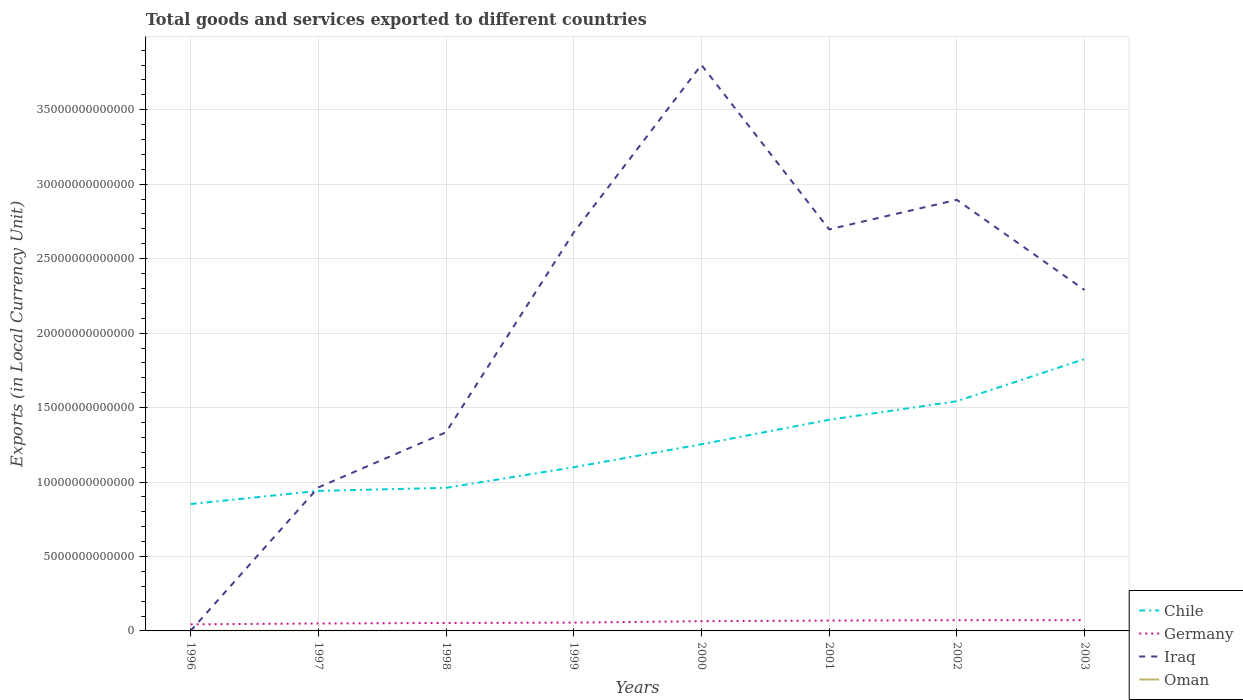How many different coloured lines are there?
Provide a succinct answer. 4. Does the line corresponding to Germany intersect with the line corresponding to Oman?
Keep it short and to the point. No. Is the number of lines equal to the number of legend labels?
Make the answer very short. Yes. Across all years, what is the maximum Amount of goods and services exports in Iraq?
Provide a short and direct response. 5.96e+08. What is the total Amount of goods and services exports in Oman in the graph?
Keep it short and to the point. -1.09e+09. What is the difference between the highest and the second highest Amount of goods and services exports in Germany?
Your response must be concise. 2.82e+11. How many lines are there?
Give a very brief answer. 4. What is the difference between two consecutive major ticks on the Y-axis?
Give a very brief answer. 5.00e+12. Are the values on the major ticks of Y-axis written in scientific E-notation?
Give a very brief answer. No. Does the graph contain any zero values?
Offer a very short reply. No. Does the graph contain grids?
Your answer should be very brief. Yes. Where does the legend appear in the graph?
Offer a very short reply. Bottom right. What is the title of the graph?
Your answer should be compact. Total goods and services exported to different countries. Does "Liechtenstein" appear as one of the legend labels in the graph?
Provide a short and direct response. No. What is the label or title of the X-axis?
Offer a very short reply. Years. What is the label or title of the Y-axis?
Ensure brevity in your answer.  Exports (in Local Currency Unit). What is the Exports (in Local Currency Unit) of Chile in 1996?
Ensure brevity in your answer.  8.52e+12. What is the Exports (in Local Currency Unit) in Germany in 1996?
Offer a terse response. 4.41e+11. What is the Exports (in Local Currency Unit) of Iraq in 1996?
Offer a very short reply. 5.96e+08. What is the Exports (in Local Currency Unit) in Oman in 1996?
Offer a very short reply. 2.93e+09. What is the Exports (in Local Currency Unit) in Chile in 1997?
Ensure brevity in your answer.  9.40e+12. What is the Exports (in Local Currency Unit) in Germany in 1997?
Provide a short and direct response. 4.99e+11. What is the Exports (in Local Currency Unit) in Iraq in 1997?
Provide a succinct answer. 9.64e+12. What is the Exports (in Local Currency Unit) of Oman in 1997?
Your response must be concise. 3.05e+09. What is the Exports (in Local Currency Unit) of Chile in 1998?
Offer a very short reply. 9.61e+12. What is the Exports (in Local Currency Unit) in Germany in 1998?
Your answer should be compact. 5.34e+11. What is the Exports (in Local Currency Unit) of Iraq in 1998?
Your response must be concise. 1.33e+13. What is the Exports (in Local Currency Unit) of Oman in 1998?
Provide a succinct answer. 2.27e+09. What is the Exports (in Local Currency Unit) in Chile in 1999?
Give a very brief answer. 1.10e+13. What is the Exports (in Local Currency Unit) of Germany in 1999?
Offer a very short reply. 5.58e+11. What is the Exports (in Local Currency Unit) of Iraq in 1999?
Your answer should be compact. 2.68e+13. What is the Exports (in Local Currency Unit) in Oman in 1999?
Offer a very short reply. 2.94e+09. What is the Exports (in Local Currency Unit) in Chile in 2000?
Give a very brief answer. 1.25e+13. What is the Exports (in Local Currency Unit) in Germany in 2000?
Your response must be concise. 6.53e+11. What is the Exports (in Local Currency Unit) in Iraq in 2000?
Give a very brief answer. 3.80e+13. What is the Exports (in Local Currency Unit) in Oman in 2000?
Make the answer very short. 4.03e+09. What is the Exports (in Local Currency Unit) in Chile in 2001?
Provide a short and direct response. 1.42e+13. What is the Exports (in Local Currency Unit) in Germany in 2001?
Make the answer very short. 6.95e+11. What is the Exports (in Local Currency Unit) of Iraq in 2001?
Your answer should be very brief. 2.70e+13. What is the Exports (in Local Currency Unit) of Oman in 2001?
Keep it short and to the point. 3.87e+09. What is the Exports (in Local Currency Unit) of Chile in 2002?
Your answer should be very brief. 1.54e+13. What is the Exports (in Local Currency Unit) in Germany in 2002?
Ensure brevity in your answer.  7.20e+11. What is the Exports (in Local Currency Unit) in Iraq in 2002?
Give a very brief answer. 2.89e+13. What is the Exports (in Local Currency Unit) of Oman in 2002?
Your answer should be compact. 3.80e+09. What is the Exports (in Local Currency Unit) of Chile in 2003?
Keep it short and to the point. 1.83e+13. What is the Exports (in Local Currency Unit) of Germany in 2003?
Provide a succinct answer. 7.24e+11. What is the Exports (in Local Currency Unit) in Iraq in 2003?
Offer a very short reply. 2.29e+13. What is the Exports (in Local Currency Unit) of Oman in 2003?
Your answer should be very brief. 4.14e+09. Across all years, what is the maximum Exports (in Local Currency Unit) in Chile?
Offer a very short reply. 1.83e+13. Across all years, what is the maximum Exports (in Local Currency Unit) of Germany?
Offer a terse response. 7.24e+11. Across all years, what is the maximum Exports (in Local Currency Unit) of Iraq?
Make the answer very short. 3.80e+13. Across all years, what is the maximum Exports (in Local Currency Unit) in Oman?
Provide a short and direct response. 4.14e+09. Across all years, what is the minimum Exports (in Local Currency Unit) of Chile?
Offer a terse response. 8.52e+12. Across all years, what is the minimum Exports (in Local Currency Unit) of Germany?
Offer a very short reply. 4.41e+11. Across all years, what is the minimum Exports (in Local Currency Unit) of Iraq?
Your answer should be compact. 5.96e+08. Across all years, what is the minimum Exports (in Local Currency Unit) of Oman?
Your answer should be very brief. 2.27e+09. What is the total Exports (in Local Currency Unit) in Chile in the graph?
Ensure brevity in your answer.  9.89e+13. What is the total Exports (in Local Currency Unit) of Germany in the graph?
Your answer should be very brief. 4.82e+12. What is the total Exports (in Local Currency Unit) in Iraq in the graph?
Keep it short and to the point. 1.67e+14. What is the total Exports (in Local Currency Unit) of Oman in the graph?
Your response must be concise. 2.70e+1. What is the difference between the Exports (in Local Currency Unit) in Chile in 1996 and that in 1997?
Keep it short and to the point. -8.84e+11. What is the difference between the Exports (in Local Currency Unit) in Germany in 1996 and that in 1997?
Your answer should be compact. -5.82e+1. What is the difference between the Exports (in Local Currency Unit) of Iraq in 1996 and that in 1997?
Provide a short and direct response. -9.64e+12. What is the difference between the Exports (in Local Currency Unit) of Oman in 1996 and that in 1997?
Make the answer very short. -1.21e+08. What is the difference between the Exports (in Local Currency Unit) of Chile in 1996 and that in 1998?
Give a very brief answer. -1.09e+12. What is the difference between the Exports (in Local Currency Unit) in Germany in 1996 and that in 1998?
Provide a succinct answer. -9.26e+1. What is the difference between the Exports (in Local Currency Unit) in Iraq in 1996 and that in 1998?
Offer a very short reply. -1.33e+13. What is the difference between the Exports (in Local Currency Unit) of Oman in 1996 and that in 1998?
Your answer should be compact. 6.53e+08. What is the difference between the Exports (in Local Currency Unit) in Chile in 1996 and that in 1999?
Ensure brevity in your answer.  -2.47e+12. What is the difference between the Exports (in Local Currency Unit) in Germany in 1996 and that in 1999?
Offer a terse response. -1.17e+11. What is the difference between the Exports (in Local Currency Unit) in Iraq in 1996 and that in 1999?
Provide a short and direct response. -2.68e+13. What is the difference between the Exports (in Local Currency Unit) of Oman in 1996 and that in 1999?
Offer a terse response. -1.50e+07. What is the difference between the Exports (in Local Currency Unit) of Chile in 1996 and that in 2000?
Your response must be concise. -4.01e+12. What is the difference between the Exports (in Local Currency Unit) of Germany in 1996 and that in 2000?
Provide a short and direct response. -2.11e+11. What is the difference between the Exports (in Local Currency Unit) of Iraq in 1996 and that in 2000?
Provide a short and direct response. -3.80e+13. What is the difference between the Exports (in Local Currency Unit) of Oman in 1996 and that in 2000?
Make the answer very short. -1.10e+09. What is the difference between the Exports (in Local Currency Unit) of Chile in 1996 and that in 2001?
Offer a very short reply. -5.66e+12. What is the difference between the Exports (in Local Currency Unit) in Germany in 1996 and that in 2001?
Your answer should be compact. -2.53e+11. What is the difference between the Exports (in Local Currency Unit) in Iraq in 1996 and that in 2001?
Provide a short and direct response. -2.70e+13. What is the difference between the Exports (in Local Currency Unit) of Oman in 1996 and that in 2001?
Make the answer very short. -9.41e+08. What is the difference between the Exports (in Local Currency Unit) of Chile in 1996 and that in 2002?
Offer a terse response. -6.91e+12. What is the difference between the Exports (in Local Currency Unit) of Germany in 1996 and that in 2002?
Your answer should be compact. -2.78e+11. What is the difference between the Exports (in Local Currency Unit) of Iraq in 1996 and that in 2002?
Provide a succinct answer. -2.89e+13. What is the difference between the Exports (in Local Currency Unit) in Oman in 1996 and that in 2002?
Your answer should be very brief. -8.77e+08. What is the difference between the Exports (in Local Currency Unit) in Chile in 1996 and that in 2003?
Your answer should be compact. -9.74e+12. What is the difference between the Exports (in Local Currency Unit) in Germany in 1996 and that in 2003?
Give a very brief answer. -2.82e+11. What is the difference between the Exports (in Local Currency Unit) in Iraq in 1996 and that in 2003?
Keep it short and to the point. -2.29e+13. What is the difference between the Exports (in Local Currency Unit) in Oman in 1996 and that in 2003?
Ensure brevity in your answer.  -1.21e+09. What is the difference between the Exports (in Local Currency Unit) in Chile in 1997 and that in 1998?
Provide a succinct answer. -2.04e+11. What is the difference between the Exports (in Local Currency Unit) in Germany in 1997 and that in 1998?
Provide a short and direct response. -3.44e+1. What is the difference between the Exports (in Local Currency Unit) of Iraq in 1997 and that in 1998?
Provide a short and direct response. -3.70e+12. What is the difference between the Exports (in Local Currency Unit) in Oman in 1997 and that in 1998?
Keep it short and to the point. 7.74e+08. What is the difference between the Exports (in Local Currency Unit) of Chile in 1997 and that in 1999?
Make the answer very short. -1.59e+12. What is the difference between the Exports (in Local Currency Unit) of Germany in 1997 and that in 1999?
Provide a short and direct response. -5.89e+1. What is the difference between the Exports (in Local Currency Unit) in Iraq in 1997 and that in 1999?
Provide a short and direct response. -1.71e+13. What is the difference between the Exports (in Local Currency Unit) in Oman in 1997 and that in 1999?
Offer a terse response. 1.06e+08. What is the difference between the Exports (in Local Currency Unit) of Chile in 1997 and that in 2000?
Ensure brevity in your answer.  -3.13e+12. What is the difference between the Exports (in Local Currency Unit) of Germany in 1997 and that in 2000?
Provide a short and direct response. -1.53e+11. What is the difference between the Exports (in Local Currency Unit) in Iraq in 1997 and that in 2000?
Provide a short and direct response. -2.84e+13. What is the difference between the Exports (in Local Currency Unit) in Oman in 1997 and that in 2000?
Provide a short and direct response. -9.80e+08. What is the difference between the Exports (in Local Currency Unit) in Chile in 1997 and that in 2001?
Keep it short and to the point. -4.78e+12. What is the difference between the Exports (in Local Currency Unit) in Germany in 1997 and that in 2001?
Your answer should be very brief. -1.95e+11. What is the difference between the Exports (in Local Currency Unit) in Iraq in 1997 and that in 2001?
Provide a short and direct response. -1.73e+13. What is the difference between the Exports (in Local Currency Unit) of Oman in 1997 and that in 2001?
Your answer should be compact. -8.20e+08. What is the difference between the Exports (in Local Currency Unit) of Chile in 1997 and that in 2002?
Provide a succinct answer. -6.02e+12. What is the difference between the Exports (in Local Currency Unit) of Germany in 1997 and that in 2002?
Provide a succinct answer. -2.20e+11. What is the difference between the Exports (in Local Currency Unit) of Iraq in 1997 and that in 2002?
Your response must be concise. -1.93e+13. What is the difference between the Exports (in Local Currency Unit) of Oman in 1997 and that in 2002?
Ensure brevity in your answer.  -7.56e+08. What is the difference between the Exports (in Local Currency Unit) in Chile in 1997 and that in 2003?
Keep it short and to the point. -8.85e+12. What is the difference between the Exports (in Local Currency Unit) in Germany in 1997 and that in 2003?
Your answer should be very brief. -2.24e+11. What is the difference between the Exports (in Local Currency Unit) in Iraq in 1997 and that in 2003?
Keep it short and to the point. -1.33e+13. What is the difference between the Exports (in Local Currency Unit) in Oman in 1997 and that in 2003?
Offer a terse response. -1.09e+09. What is the difference between the Exports (in Local Currency Unit) in Chile in 1998 and that in 1999?
Make the answer very short. -1.38e+12. What is the difference between the Exports (in Local Currency Unit) of Germany in 1998 and that in 1999?
Your answer should be compact. -2.45e+1. What is the difference between the Exports (in Local Currency Unit) of Iraq in 1998 and that in 1999?
Your answer should be compact. -1.34e+13. What is the difference between the Exports (in Local Currency Unit) in Oman in 1998 and that in 1999?
Your answer should be compact. -6.68e+08. What is the difference between the Exports (in Local Currency Unit) in Chile in 1998 and that in 2000?
Provide a succinct answer. -2.93e+12. What is the difference between the Exports (in Local Currency Unit) in Germany in 1998 and that in 2000?
Make the answer very short. -1.19e+11. What is the difference between the Exports (in Local Currency Unit) of Iraq in 1998 and that in 2000?
Your answer should be very brief. -2.47e+13. What is the difference between the Exports (in Local Currency Unit) in Oman in 1998 and that in 2000?
Your answer should be compact. -1.75e+09. What is the difference between the Exports (in Local Currency Unit) of Chile in 1998 and that in 2001?
Ensure brevity in your answer.  -4.57e+12. What is the difference between the Exports (in Local Currency Unit) of Germany in 1998 and that in 2001?
Make the answer very short. -1.61e+11. What is the difference between the Exports (in Local Currency Unit) in Iraq in 1998 and that in 2001?
Give a very brief answer. -1.36e+13. What is the difference between the Exports (in Local Currency Unit) of Oman in 1998 and that in 2001?
Your answer should be very brief. -1.59e+09. What is the difference between the Exports (in Local Currency Unit) in Chile in 1998 and that in 2002?
Your response must be concise. -5.82e+12. What is the difference between the Exports (in Local Currency Unit) in Germany in 1998 and that in 2002?
Give a very brief answer. -1.86e+11. What is the difference between the Exports (in Local Currency Unit) of Iraq in 1998 and that in 2002?
Ensure brevity in your answer.  -1.56e+13. What is the difference between the Exports (in Local Currency Unit) in Oman in 1998 and that in 2002?
Offer a very short reply. -1.53e+09. What is the difference between the Exports (in Local Currency Unit) in Chile in 1998 and that in 2003?
Give a very brief answer. -8.65e+12. What is the difference between the Exports (in Local Currency Unit) in Germany in 1998 and that in 2003?
Ensure brevity in your answer.  -1.90e+11. What is the difference between the Exports (in Local Currency Unit) in Iraq in 1998 and that in 2003?
Make the answer very short. -9.56e+12. What is the difference between the Exports (in Local Currency Unit) of Oman in 1998 and that in 2003?
Keep it short and to the point. -1.87e+09. What is the difference between the Exports (in Local Currency Unit) in Chile in 1999 and that in 2000?
Make the answer very short. -1.54e+12. What is the difference between the Exports (in Local Currency Unit) in Germany in 1999 and that in 2000?
Give a very brief answer. -9.41e+1. What is the difference between the Exports (in Local Currency Unit) in Iraq in 1999 and that in 2000?
Your answer should be compact. -1.13e+13. What is the difference between the Exports (in Local Currency Unit) of Oman in 1999 and that in 2000?
Offer a very short reply. -1.09e+09. What is the difference between the Exports (in Local Currency Unit) in Chile in 1999 and that in 2001?
Provide a succinct answer. -3.19e+12. What is the difference between the Exports (in Local Currency Unit) of Germany in 1999 and that in 2001?
Ensure brevity in your answer.  -1.36e+11. What is the difference between the Exports (in Local Currency Unit) of Iraq in 1999 and that in 2001?
Keep it short and to the point. -2.11e+11. What is the difference between the Exports (in Local Currency Unit) of Oman in 1999 and that in 2001?
Offer a very short reply. -9.26e+08. What is the difference between the Exports (in Local Currency Unit) of Chile in 1999 and that in 2002?
Your response must be concise. -4.43e+12. What is the difference between the Exports (in Local Currency Unit) in Germany in 1999 and that in 2002?
Your answer should be very brief. -1.61e+11. What is the difference between the Exports (in Local Currency Unit) in Iraq in 1999 and that in 2002?
Offer a very short reply. -2.19e+12. What is the difference between the Exports (in Local Currency Unit) of Oman in 1999 and that in 2002?
Give a very brief answer. -8.62e+08. What is the difference between the Exports (in Local Currency Unit) of Chile in 1999 and that in 2003?
Give a very brief answer. -7.26e+12. What is the difference between the Exports (in Local Currency Unit) in Germany in 1999 and that in 2003?
Your answer should be compact. -1.65e+11. What is the difference between the Exports (in Local Currency Unit) in Iraq in 1999 and that in 2003?
Make the answer very short. 3.86e+12. What is the difference between the Exports (in Local Currency Unit) in Oman in 1999 and that in 2003?
Provide a short and direct response. -1.20e+09. What is the difference between the Exports (in Local Currency Unit) in Chile in 2000 and that in 2001?
Offer a very short reply. -1.65e+12. What is the difference between the Exports (in Local Currency Unit) in Germany in 2000 and that in 2001?
Your answer should be very brief. -4.22e+1. What is the difference between the Exports (in Local Currency Unit) of Iraq in 2000 and that in 2001?
Provide a succinct answer. 1.10e+13. What is the difference between the Exports (in Local Currency Unit) in Oman in 2000 and that in 2001?
Offer a terse response. 1.60e+08. What is the difference between the Exports (in Local Currency Unit) of Chile in 2000 and that in 2002?
Keep it short and to the point. -2.89e+12. What is the difference between the Exports (in Local Currency Unit) in Germany in 2000 and that in 2002?
Make the answer very short. -6.72e+1. What is the difference between the Exports (in Local Currency Unit) of Iraq in 2000 and that in 2002?
Give a very brief answer. 9.06e+12. What is the difference between the Exports (in Local Currency Unit) in Oman in 2000 and that in 2002?
Your response must be concise. 2.24e+08. What is the difference between the Exports (in Local Currency Unit) of Chile in 2000 and that in 2003?
Make the answer very short. -5.72e+12. What is the difference between the Exports (in Local Currency Unit) in Germany in 2000 and that in 2003?
Your answer should be very brief. -7.11e+1. What is the difference between the Exports (in Local Currency Unit) in Iraq in 2000 and that in 2003?
Offer a terse response. 1.51e+13. What is the difference between the Exports (in Local Currency Unit) of Oman in 2000 and that in 2003?
Give a very brief answer. -1.12e+08. What is the difference between the Exports (in Local Currency Unit) of Chile in 2001 and that in 2002?
Provide a succinct answer. -1.25e+12. What is the difference between the Exports (in Local Currency Unit) in Germany in 2001 and that in 2002?
Offer a very short reply. -2.49e+1. What is the difference between the Exports (in Local Currency Unit) of Iraq in 2001 and that in 2002?
Offer a terse response. -1.98e+12. What is the difference between the Exports (in Local Currency Unit) of Oman in 2001 and that in 2002?
Offer a very short reply. 6.40e+07. What is the difference between the Exports (in Local Currency Unit) in Chile in 2001 and that in 2003?
Provide a succinct answer. -4.08e+12. What is the difference between the Exports (in Local Currency Unit) of Germany in 2001 and that in 2003?
Provide a short and direct response. -2.88e+1. What is the difference between the Exports (in Local Currency Unit) in Iraq in 2001 and that in 2003?
Keep it short and to the point. 4.07e+12. What is the difference between the Exports (in Local Currency Unit) in Oman in 2001 and that in 2003?
Offer a terse response. -2.72e+08. What is the difference between the Exports (in Local Currency Unit) of Chile in 2002 and that in 2003?
Provide a short and direct response. -2.83e+12. What is the difference between the Exports (in Local Currency Unit) in Germany in 2002 and that in 2003?
Give a very brief answer. -3.90e+09. What is the difference between the Exports (in Local Currency Unit) in Iraq in 2002 and that in 2003?
Provide a succinct answer. 6.05e+12. What is the difference between the Exports (in Local Currency Unit) of Oman in 2002 and that in 2003?
Your answer should be very brief. -3.36e+08. What is the difference between the Exports (in Local Currency Unit) of Chile in 1996 and the Exports (in Local Currency Unit) of Germany in 1997?
Offer a terse response. 8.02e+12. What is the difference between the Exports (in Local Currency Unit) of Chile in 1996 and the Exports (in Local Currency Unit) of Iraq in 1997?
Keep it short and to the point. -1.12e+12. What is the difference between the Exports (in Local Currency Unit) in Chile in 1996 and the Exports (in Local Currency Unit) in Oman in 1997?
Provide a succinct answer. 8.52e+12. What is the difference between the Exports (in Local Currency Unit) in Germany in 1996 and the Exports (in Local Currency Unit) in Iraq in 1997?
Provide a short and direct response. -9.20e+12. What is the difference between the Exports (in Local Currency Unit) in Germany in 1996 and the Exports (in Local Currency Unit) in Oman in 1997?
Ensure brevity in your answer.  4.38e+11. What is the difference between the Exports (in Local Currency Unit) in Iraq in 1996 and the Exports (in Local Currency Unit) in Oman in 1997?
Your answer should be compact. -2.45e+09. What is the difference between the Exports (in Local Currency Unit) in Chile in 1996 and the Exports (in Local Currency Unit) in Germany in 1998?
Make the answer very short. 7.99e+12. What is the difference between the Exports (in Local Currency Unit) in Chile in 1996 and the Exports (in Local Currency Unit) in Iraq in 1998?
Your response must be concise. -4.82e+12. What is the difference between the Exports (in Local Currency Unit) in Chile in 1996 and the Exports (in Local Currency Unit) in Oman in 1998?
Your response must be concise. 8.52e+12. What is the difference between the Exports (in Local Currency Unit) of Germany in 1996 and the Exports (in Local Currency Unit) of Iraq in 1998?
Make the answer very short. -1.29e+13. What is the difference between the Exports (in Local Currency Unit) of Germany in 1996 and the Exports (in Local Currency Unit) of Oman in 1998?
Your response must be concise. 4.39e+11. What is the difference between the Exports (in Local Currency Unit) of Iraq in 1996 and the Exports (in Local Currency Unit) of Oman in 1998?
Make the answer very short. -1.68e+09. What is the difference between the Exports (in Local Currency Unit) of Chile in 1996 and the Exports (in Local Currency Unit) of Germany in 1999?
Make the answer very short. 7.96e+12. What is the difference between the Exports (in Local Currency Unit) in Chile in 1996 and the Exports (in Local Currency Unit) in Iraq in 1999?
Offer a terse response. -1.82e+13. What is the difference between the Exports (in Local Currency Unit) of Chile in 1996 and the Exports (in Local Currency Unit) of Oman in 1999?
Give a very brief answer. 8.52e+12. What is the difference between the Exports (in Local Currency Unit) of Germany in 1996 and the Exports (in Local Currency Unit) of Iraq in 1999?
Provide a short and direct response. -2.63e+13. What is the difference between the Exports (in Local Currency Unit) of Germany in 1996 and the Exports (in Local Currency Unit) of Oman in 1999?
Provide a succinct answer. 4.38e+11. What is the difference between the Exports (in Local Currency Unit) of Iraq in 1996 and the Exports (in Local Currency Unit) of Oman in 1999?
Ensure brevity in your answer.  -2.35e+09. What is the difference between the Exports (in Local Currency Unit) of Chile in 1996 and the Exports (in Local Currency Unit) of Germany in 2000?
Offer a terse response. 7.87e+12. What is the difference between the Exports (in Local Currency Unit) in Chile in 1996 and the Exports (in Local Currency Unit) in Iraq in 2000?
Ensure brevity in your answer.  -2.95e+13. What is the difference between the Exports (in Local Currency Unit) of Chile in 1996 and the Exports (in Local Currency Unit) of Oman in 2000?
Offer a terse response. 8.52e+12. What is the difference between the Exports (in Local Currency Unit) in Germany in 1996 and the Exports (in Local Currency Unit) in Iraq in 2000?
Offer a terse response. -3.76e+13. What is the difference between the Exports (in Local Currency Unit) of Germany in 1996 and the Exports (in Local Currency Unit) of Oman in 2000?
Provide a succinct answer. 4.37e+11. What is the difference between the Exports (in Local Currency Unit) in Iraq in 1996 and the Exports (in Local Currency Unit) in Oman in 2000?
Your response must be concise. -3.43e+09. What is the difference between the Exports (in Local Currency Unit) of Chile in 1996 and the Exports (in Local Currency Unit) of Germany in 2001?
Ensure brevity in your answer.  7.83e+12. What is the difference between the Exports (in Local Currency Unit) in Chile in 1996 and the Exports (in Local Currency Unit) in Iraq in 2001?
Offer a terse response. -1.84e+13. What is the difference between the Exports (in Local Currency Unit) of Chile in 1996 and the Exports (in Local Currency Unit) of Oman in 2001?
Offer a very short reply. 8.52e+12. What is the difference between the Exports (in Local Currency Unit) in Germany in 1996 and the Exports (in Local Currency Unit) in Iraq in 2001?
Keep it short and to the point. -2.65e+13. What is the difference between the Exports (in Local Currency Unit) of Germany in 1996 and the Exports (in Local Currency Unit) of Oman in 2001?
Provide a succinct answer. 4.37e+11. What is the difference between the Exports (in Local Currency Unit) of Iraq in 1996 and the Exports (in Local Currency Unit) of Oman in 2001?
Give a very brief answer. -3.27e+09. What is the difference between the Exports (in Local Currency Unit) in Chile in 1996 and the Exports (in Local Currency Unit) in Germany in 2002?
Offer a very short reply. 7.80e+12. What is the difference between the Exports (in Local Currency Unit) of Chile in 1996 and the Exports (in Local Currency Unit) of Iraq in 2002?
Keep it short and to the point. -2.04e+13. What is the difference between the Exports (in Local Currency Unit) in Chile in 1996 and the Exports (in Local Currency Unit) in Oman in 2002?
Provide a short and direct response. 8.52e+12. What is the difference between the Exports (in Local Currency Unit) in Germany in 1996 and the Exports (in Local Currency Unit) in Iraq in 2002?
Offer a very short reply. -2.85e+13. What is the difference between the Exports (in Local Currency Unit) in Germany in 1996 and the Exports (in Local Currency Unit) in Oman in 2002?
Your answer should be very brief. 4.37e+11. What is the difference between the Exports (in Local Currency Unit) in Iraq in 1996 and the Exports (in Local Currency Unit) in Oman in 2002?
Make the answer very short. -3.21e+09. What is the difference between the Exports (in Local Currency Unit) of Chile in 1996 and the Exports (in Local Currency Unit) of Germany in 2003?
Ensure brevity in your answer.  7.80e+12. What is the difference between the Exports (in Local Currency Unit) of Chile in 1996 and the Exports (in Local Currency Unit) of Iraq in 2003?
Your response must be concise. -1.44e+13. What is the difference between the Exports (in Local Currency Unit) in Chile in 1996 and the Exports (in Local Currency Unit) in Oman in 2003?
Your response must be concise. 8.52e+12. What is the difference between the Exports (in Local Currency Unit) in Germany in 1996 and the Exports (in Local Currency Unit) in Iraq in 2003?
Provide a succinct answer. -2.25e+13. What is the difference between the Exports (in Local Currency Unit) in Germany in 1996 and the Exports (in Local Currency Unit) in Oman in 2003?
Offer a very short reply. 4.37e+11. What is the difference between the Exports (in Local Currency Unit) in Iraq in 1996 and the Exports (in Local Currency Unit) in Oman in 2003?
Your answer should be compact. -3.54e+09. What is the difference between the Exports (in Local Currency Unit) of Chile in 1997 and the Exports (in Local Currency Unit) of Germany in 1998?
Offer a terse response. 8.87e+12. What is the difference between the Exports (in Local Currency Unit) of Chile in 1997 and the Exports (in Local Currency Unit) of Iraq in 1998?
Make the answer very short. -3.94e+12. What is the difference between the Exports (in Local Currency Unit) of Chile in 1997 and the Exports (in Local Currency Unit) of Oman in 1998?
Offer a terse response. 9.40e+12. What is the difference between the Exports (in Local Currency Unit) of Germany in 1997 and the Exports (in Local Currency Unit) of Iraq in 1998?
Your answer should be compact. -1.28e+13. What is the difference between the Exports (in Local Currency Unit) of Germany in 1997 and the Exports (in Local Currency Unit) of Oman in 1998?
Provide a succinct answer. 4.97e+11. What is the difference between the Exports (in Local Currency Unit) in Iraq in 1997 and the Exports (in Local Currency Unit) in Oman in 1998?
Give a very brief answer. 9.63e+12. What is the difference between the Exports (in Local Currency Unit) in Chile in 1997 and the Exports (in Local Currency Unit) in Germany in 1999?
Give a very brief answer. 8.85e+12. What is the difference between the Exports (in Local Currency Unit) in Chile in 1997 and the Exports (in Local Currency Unit) in Iraq in 1999?
Keep it short and to the point. -1.74e+13. What is the difference between the Exports (in Local Currency Unit) in Chile in 1997 and the Exports (in Local Currency Unit) in Oman in 1999?
Provide a succinct answer. 9.40e+12. What is the difference between the Exports (in Local Currency Unit) in Germany in 1997 and the Exports (in Local Currency Unit) in Iraq in 1999?
Give a very brief answer. -2.63e+13. What is the difference between the Exports (in Local Currency Unit) of Germany in 1997 and the Exports (in Local Currency Unit) of Oman in 1999?
Provide a succinct answer. 4.97e+11. What is the difference between the Exports (in Local Currency Unit) in Iraq in 1997 and the Exports (in Local Currency Unit) in Oman in 1999?
Provide a short and direct response. 9.63e+12. What is the difference between the Exports (in Local Currency Unit) in Chile in 1997 and the Exports (in Local Currency Unit) in Germany in 2000?
Offer a terse response. 8.75e+12. What is the difference between the Exports (in Local Currency Unit) of Chile in 1997 and the Exports (in Local Currency Unit) of Iraq in 2000?
Make the answer very short. -2.86e+13. What is the difference between the Exports (in Local Currency Unit) of Chile in 1997 and the Exports (in Local Currency Unit) of Oman in 2000?
Give a very brief answer. 9.40e+12. What is the difference between the Exports (in Local Currency Unit) in Germany in 1997 and the Exports (in Local Currency Unit) in Iraq in 2000?
Ensure brevity in your answer.  -3.75e+13. What is the difference between the Exports (in Local Currency Unit) in Germany in 1997 and the Exports (in Local Currency Unit) in Oman in 2000?
Provide a short and direct response. 4.95e+11. What is the difference between the Exports (in Local Currency Unit) in Iraq in 1997 and the Exports (in Local Currency Unit) in Oman in 2000?
Your answer should be very brief. 9.63e+12. What is the difference between the Exports (in Local Currency Unit) in Chile in 1997 and the Exports (in Local Currency Unit) in Germany in 2001?
Ensure brevity in your answer.  8.71e+12. What is the difference between the Exports (in Local Currency Unit) of Chile in 1997 and the Exports (in Local Currency Unit) of Iraq in 2001?
Offer a very short reply. -1.76e+13. What is the difference between the Exports (in Local Currency Unit) of Chile in 1997 and the Exports (in Local Currency Unit) of Oman in 2001?
Offer a very short reply. 9.40e+12. What is the difference between the Exports (in Local Currency Unit) in Germany in 1997 and the Exports (in Local Currency Unit) in Iraq in 2001?
Your response must be concise. -2.65e+13. What is the difference between the Exports (in Local Currency Unit) of Germany in 1997 and the Exports (in Local Currency Unit) of Oman in 2001?
Provide a succinct answer. 4.96e+11. What is the difference between the Exports (in Local Currency Unit) in Iraq in 1997 and the Exports (in Local Currency Unit) in Oman in 2001?
Your answer should be compact. 9.63e+12. What is the difference between the Exports (in Local Currency Unit) of Chile in 1997 and the Exports (in Local Currency Unit) of Germany in 2002?
Your answer should be very brief. 8.68e+12. What is the difference between the Exports (in Local Currency Unit) in Chile in 1997 and the Exports (in Local Currency Unit) in Iraq in 2002?
Offer a terse response. -1.95e+13. What is the difference between the Exports (in Local Currency Unit) in Chile in 1997 and the Exports (in Local Currency Unit) in Oman in 2002?
Provide a succinct answer. 9.40e+12. What is the difference between the Exports (in Local Currency Unit) in Germany in 1997 and the Exports (in Local Currency Unit) in Iraq in 2002?
Make the answer very short. -2.85e+13. What is the difference between the Exports (in Local Currency Unit) of Germany in 1997 and the Exports (in Local Currency Unit) of Oman in 2002?
Your response must be concise. 4.96e+11. What is the difference between the Exports (in Local Currency Unit) of Iraq in 1997 and the Exports (in Local Currency Unit) of Oman in 2002?
Give a very brief answer. 9.63e+12. What is the difference between the Exports (in Local Currency Unit) in Chile in 1997 and the Exports (in Local Currency Unit) in Germany in 2003?
Keep it short and to the point. 8.68e+12. What is the difference between the Exports (in Local Currency Unit) in Chile in 1997 and the Exports (in Local Currency Unit) in Iraq in 2003?
Give a very brief answer. -1.35e+13. What is the difference between the Exports (in Local Currency Unit) of Chile in 1997 and the Exports (in Local Currency Unit) of Oman in 2003?
Make the answer very short. 9.40e+12. What is the difference between the Exports (in Local Currency Unit) in Germany in 1997 and the Exports (in Local Currency Unit) in Iraq in 2003?
Offer a very short reply. -2.24e+13. What is the difference between the Exports (in Local Currency Unit) of Germany in 1997 and the Exports (in Local Currency Unit) of Oman in 2003?
Your answer should be compact. 4.95e+11. What is the difference between the Exports (in Local Currency Unit) of Iraq in 1997 and the Exports (in Local Currency Unit) of Oman in 2003?
Provide a short and direct response. 9.63e+12. What is the difference between the Exports (in Local Currency Unit) in Chile in 1998 and the Exports (in Local Currency Unit) in Germany in 1999?
Your answer should be very brief. 9.05e+12. What is the difference between the Exports (in Local Currency Unit) in Chile in 1998 and the Exports (in Local Currency Unit) in Iraq in 1999?
Offer a terse response. -1.71e+13. What is the difference between the Exports (in Local Currency Unit) in Chile in 1998 and the Exports (in Local Currency Unit) in Oman in 1999?
Your answer should be compact. 9.61e+12. What is the difference between the Exports (in Local Currency Unit) in Germany in 1998 and the Exports (in Local Currency Unit) in Iraq in 1999?
Keep it short and to the point. -2.62e+13. What is the difference between the Exports (in Local Currency Unit) of Germany in 1998 and the Exports (in Local Currency Unit) of Oman in 1999?
Provide a succinct answer. 5.31e+11. What is the difference between the Exports (in Local Currency Unit) of Iraq in 1998 and the Exports (in Local Currency Unit) of Oman in 1999?
Your answer should be very brief. 1.33e+13. What is the difference between the Exports (in Local Currency Unit) of Chile in 1998 and the Exports (in Local Currency Unit) of Germany in 2000?
Your response must be concise. 8.96e+12. What is the difference between the Exports (in Local Currency Unit) in Chile in 1998 and the Exports (in Local Currency Unit) in Iraq in 2000?
Offer a terse response. -2.84e+13. What is the difference between the Exports (in Local Currency Unit) of Chile in 1998 and the Exports (in Local Currency Unit) of Oman in 2000?
Offer a terse response. 9.60e+12. What is the difference between the Exports (in Local Currency Unit) of Germany in 1998 and the Exports (in Local Currency Unit) of Iraq in 2000?
Make the answer very short. -3.75e+13. What is the difference between the Exports (in Local Currency Unit) in Germany in 1998 and the Exports (in Local Currency Unit) in Oman in 2000?
Your answer should be very brief. 5.30e+11. What is the difference between the Exports (in Local Currency Unit) in Iraq in 1998 and the Exports (in Local Currency Unit) in Oman in 2000?
Make the answer very short. 1.33e+13. What is the difference between the Exports (in Local Currency Unit) in Chile in 1998 and the Exports (in Local Currency Unit) in Germany in 2001?
Keep it short and to the point. 8.91e+12. What is the difference between the Exports (in Local Currency Unit) in Chile in 1998 and the Exports (in Local Currency Unit) in Iraq in 2001?
Your answer should be compact. -1.74e+13. What is the difference between the Exports (in Local Currency Unit) in Chile in 1998 and the Exports (in Local Currency Unit) in Oman in 2001?
Keep it short and to the point. 9.60e+12. What is the difference between the Exports (in Local Currency Unit) in Germany in 1998 and the Exports (in Local Currency Unit) in Iraq in 2001?
Your response must be concise. -2.64e+13. What is the difference between the Exports (in Local Currency Unit) in Germany in 1998 and the Exports (in Local Currency Unit) in Oman in 2001?
Make the answer very short. 5.30e+11. What is the difference between the Exports (in Local Currency Unit) in Iraq in 1998 and the Exports (in Local Currency Unit) in Oman in 2001?
Keep it short and to the point. 1.33e+13. What is the difference between the Exports (in Local Currency Unit) of Chile in 1998 and the Exports (in Local Currency Unit) of Germany in 2002?
Ensure brevity in your answer.  8.89e+12. What is the difference between the Exports (in Local Currency Unit) of Chile in 1998 and the Exports (in Local Currency Unit) of Iraq in 2002?
Your answer should be very brief. -1.93e+13. What is the difference between the Exports (in Local Currency Unit) of Chile in 1998 and the Exports (in Local Currency Unit) of Oman in 2002?
Ensure brevity in your answer.  9.60e+12. What is the difference between the Exports (in Local Currency Unit) of Germany in 1998 and the Exports (in Local Currency Unit) of Iraq in 2002?
Provide a succinct answer. -2.84e+13. What is the difference between the Exports (in Local Currency Unit) in Germany in 1998 and the Exports (in Local Currency Unit) in Oman in 2002?
Keep it short and to the point. 5.30e+11. What is the difference between the Exports (in Local Currency Unit) in Iraq in 1998 and the Exports (in Local Currency Unit) in Oman in 2002?
Your answer should be compact. 1.33e+13. What is the difference between the Exports (in Local Currency Unit) in Chile in 1998 and the Exports (in Local Currency Unit) in Germany in 2003?
Your response must be concise. 8.89e+12. What is the difference between the Exports (in Local Currency Unit) of Chile in 1998 and the Exports (in Local Currency Unit) of Iraq in 2003?
Provide a short and direct response. -1.33e+13. What is the difference between the Exports (in Local Currency Unit) of Chile in 1998 and the Exports (in Local Currency Unit) of Oman in 2003?
Make the answer very short. 9.60e+12. What is the difference between the Exports (in Local Currency Unit) in Germany in 1998 and the Exports (in Local Currency Unit) in Iraq in 2003?
Keep it short and to the point. -2.24e+13. What is the difference between the Exports (in Local Currency Unit) in Germany in 1998 and the Exports (in Local Currency Unit) in Oman in 2003?
Your response must be concise. 5.30e+11. What is the difference between the Exports (in Local Currency Unit) in Iraq in 1998 and the Exports (in Local Currency Unit) in Oman in 2003?
Ensure brevity in your answer.  1.33e+13. What is the difference between the Exports (in Local Currency Unit) in Chile in 1999 and the Exports (in Local Currency Unit) in Germany in 2000?
Give a very brief answer. 1.03e+13. What is the difference between the Exports (in Local Currency Unit) of Chile in 1999 and the Exports (in Local Currency Unit) of Iraq in 2000?
Offer a very short reply. -2.70e+13. What is the difference between the Exports (in Local Currency Unit) of Chile in 1999 and the Exports (in Local Currency Unit) of Oman in 2000?
Your answer should be compact. 1.10e+13. What is the difference between the Exports (in Local Currency Unit) of Germany in 1999 and the Exports (in Local Currency Unit) of Iraq in 2000?
Keep it short and to the point. -3.75e+13. What is the difference between the Exports (in Local Currency Unit) of Germany in 1999 and the Exports (in Local Currency Unit) of Oman in 2000?
Provide a short and direct response. 5.54e+11. What is the difference between the Exports (in Local Currency Unit) in Iraq in 1999 and the Exports (in Local Currency Unit) in Oman in 2000?
Offer a terse response. 2.68e+13. What is the difference between the Exports (in Local Currency Unit) in Chile in 1999 and the Exports (in Local Currency Unit) in Germany in 2001?
Ensure brevity in your answer.  1.03e+13. What is the difference between the Exports (in Local Currency Unit) in Chile in 1999 and the Exports (in Local Currency Unit) in Iraq in 2001?
Provide a short and direct response. -1.60e+13. What is the difference between the Exports (in Local Currency Unit) of Chile in 1999 and the Exports (in Local Currency Unit) of Oman in 2001?
Ensure brevity in your answer.  1.10e+13. What is the difference between the Exports (in Local Currency Unit) in Germany in 1999 and the Exports (in Local Currency Unit) in Iraq in 2001?
Provide a succinct answer. -2.64e+13. What is the difference between the Exports (in Local Currency Unit) in Germany in 1999 and the Exports (in Local Currency Unit) in Oman in 2001?
Provide a succinct answer. 5.55e+11. What is the difference between the Exports (in Local Currency Unit) of Iraq in 1999 and the Exports (in Local Currency Unit) of Oman in 2001?
Your answer should be compact. 2.68e+13. What is the difference between the Exports (in Local Currency Unit) of Chile in 1999 and the Exports (in Local Currency Unit) of Germany in 2002?
Offer a very short reply. 1.03e+13. What is the difference between the Exports (in Local Currency Unit) in Chile in 1999 and the Exports (in Local Currency Unit) in Iraq in 2002?
Provide a succinct answer. -1.80e+13. What is the difference between the Exports (in Local Currency Unit) in Chile in 1999 and the Exports (in Local Currency Unit) in Oman in 2002?
Provide a succinct answer. 1.10e+13. What is the difference between the Exports (in Local Currency Unit) in Germany in 1999 and the Exports (in Local Currency Unit) in Iraq in 2002?
Your response must be concise. -2.84e+13. What is the difference between the Exports (in Local Currency Unit) in Germany in 1999 and the Exports (in Local Currency Unit) in Oman in 2002?
Keep it short and to the point. 5.55e+11. What is the difference between the Exports (in Local Currency Unit) of Iraq in 1999 and the Exports (in Local Currency Unit) of Oman in 2002?
Your answer should be compact. 2.68e+13. What is the difference between the Exports (in Local Currency Unit) of Chile in 1999 and the Exports (in Local Currency Unit) of Germany in 2003?
Your answer should be very brief. 1.03e+13. What is the difference between the Exports (in Local Currency Unit) of Chile in 1999 and the Exports (in Local Currency Unit) of Iraq in 2003?
Your answer should be compact. -1.19e+13. What is the difference between the Exports (in Local Currency Unit) of Chile in 1999 and the Exports (in Local Currency Unit) of Oman in 2003?
Keep it short and to the point. 1.10e+13. What is the difference between the Exports (in Local Currency Unit) of Germany in 1999 and the Exports (in Local Currency Unit) of Iraq in 2003?
Your response must be concise. -2.23e+13. What is the difference between the Exports (in Local Currency Unit) in Germany in 1999 and the Exports (in Local Currency Unit) in Oman in 2003?
Your response must be concise. 5.54e+11. What is the difference between the Exports (in Local Currency Unit) in Iraq in 1999 and the Exports (in Local Currency Unit) in Oman in 2003?
Your response must be concise. 2.68e+13. What is the difference between the Exports (in Local Currency Unit) of Chile in 2000 and the Exports (in Local Currency Unit) of Germany in 2001?
Give a very brief answer. 1.18e+13. What is the difference between the Exports (in Local Currency Unit) in Chile in 2000 and the Exports (in Local Currency Unit) in Iraq in 2001?
Your answer should be compact. -1.44e+13. What is the difference between the Exports (in Local Currency Unit) of Chile in 2000 and the Exports (in Local Currency Unit) of Oman in 2001?
Give a very brief answer. 1.25e+13. What is the difference between the Exports (in Local Currency Unit) in Germany in 2000 and the Exports (in Local Currency Unit) in Iraq in 2001?
Your response must be concise. -2.63e+13. What is the difference between the Exports (in Local Currency Unit) in Germany in 2000 and the Exports (in Local Currency Unit) in Oman in 2001?
Make the answer very short. 6.49e+11. What is the difference between the Exports (in Local Currency Unit) in Iraq in 2000 and the Exports (in Local Currency Unit) in Oman in 2001?
Offer a terse response. 3.80e+13. What is the difference between the Exports (in Local Currency Unit) in Chile in 2000 and the Exports (in Local Currency Unit) in Germany in 2002?
Ensure brevity in your answer.  1.18e+13. What is the difference between the Exports (in Local Currency Unit) of Chile in 2000 and the Exports (in Local Currency Unit) of Iraq in 2002?
Your answer should be compact. -1.64e+13. What is the difference between the Exports (in Local Currency Unit) of Chile in 2000 and the Exports (in Local Currency Unit) of Oman in 2002?
Ensure brevity in your answer.  1.25e+13. What is the difference between the Exports (in Local Currency Unit) of Germany in 2000 and the Exports (in Local Currency Unit) of Iraq in 2002?
Provide a succinct answer. -2.83e+13. What is the difference between the Exports (in Local Currency Unit) of Germany in 2000 and the Exports (in Local Currency Unit) of Oman in 2002?
Make the answer very short. 6.49e+11. What is the difference between the Exports (in Local Currency Unit) of Iraq in 2000 and the Exports (in Local Currency Unit) of Oman in 2002?
Ensure brevity in your answer.  3.80e+13. What is the difference between the Exports (in Local Currency Unit) of Chile in 2000 and the Exports (in Local Currency Unit) of Germany in 2003?
Keep it short and to the point. 1.18e+13. What is the difference between the Exports (in Local Currency Unit) of Chile in 2000 and the Exports (in Local Currency Unit) of Iraq in 2003?
Offer a very short reply. -1.04e+13. What is the difference between the Exports (in Local Currency Unit) of Chile in 2000 and the Exports (in Local Currency Unit) of Oman in 2003?
Your answer should be very brief. 1.25e+13. What is the difference between the Exports (in Local Currency Unit) of Germany in 2000 and the Exports (in Local Currency Unit) of Iraq in 2003?
Provide a succinct answer. -2.22e+13. What is the difference between the Exports (in Local Currency Unit) in Germany in 2000 and the Exports (in Local Currency Unit) in Oman in 2003?
Your response must be concise. 6.48e+11. What is the difference between the Exports (in Local Currency Unit) of Iraq in 2000 and the Exports (in Local Currency Unit) of Oman in 2003?
Your answer should be compact. 3.80e+13. What is the difference between the Exports (in Local Currency Unit) in Chile in 2001 and the Exports (in Local Currency Unit) in Germany in 2002?
Your answer should be very brief. 1.35e+13. What is the difference between the Exports (in Local Currency Unit) of Chile in 2001 and the Exports (in Local Currency Unit) of Iraq in 2002?
Your answer should be compact. -1.48e+13. What is the difference between the Exports (in Local Currency Unit) of Chile in 2001 and the Exports (in Local Currency Unit) of Oman in 2002?
Make the answer very short. 1.42e+13. What is the difference between the Exports (in Local Currency Unit) of Germany in 2001 and the Exports (in Local Currency Unit) of Iraq in 2002?
Ensure brevity in your answer.  -2.83e+13. What is the difference between the Exports (in Local Currency Unit) in Germany in 2001 and the Exports (in Local Currency Unit) in Oman in 2002?
Your answer should be compact. 6.91e+11. What is the difference between the Exports (in Local Currency Unit) in Iraq in 2001 and the Exports (in Local Currency Unit) in Oman in 2002?
Your answer should be compact. 2.70e+13. What is the difference between the Exports (in Local Currency Unit) of Chile in 2001 and the Exports (in Local Currency Unit) of Germany in 2003?
Your answer should be very brief. 1.35e+13. What is the difference between the Exports (in Local Currency Unit) of Chile in 2001 and the Exports (in Local Currency Unit) of Iraq in 2003?
Keep it short and to the point. -8.72e+12. What is the difference between the Exports (in Local Currency Unit) of Chile in 2001 and the Exports (in Local Currency Unit) of Oman in 2003?
Provide a succinct answer. 1.42e+13. What is the difference between the Exports (in Local Currency Unit) of Germany in 2001 and the Exports (in Local Currency Unit) of Iraq in 2003?
Keep it short and to the point. -2.22e+13. What is the difference between the Exports (in Local Currency Unit) in Germany in 2001 and the Exports (in Local Currency Unit) in Oman in 2003?
Ensure brevity in your answer.  6.91e+11. What is the difference between the Exports (in Local Currency Unit) of Iraq in 2001 and the Exports (in Local Currency Unit) of Oman in 2003?
Your answer should be compact. 2.70e+13. What is the difference between the Exports (in Local Currency Unit) of Chile in 2002 and the Exports (in Local Currency Unit) of Germany in 2003?
Your response must be concise. 1.47e+13. What is the difference between the Exports (in Local Currency Unit) of Chile in 2002 and the Exports (in Local Currency Unit) of Iraq in 2003?
Provide a succinct answer. -7.47e+12. What is the difference between the Exports (in Local Currency Unit) of Chile in 2002 and the Exports (in Local Currency Unit) of Oman in 2003?
Ensure brevity in your answer.  1.54e+13. What is the difference between the Exports (in Local Currency Unit) of Germany in 2002 and the Exports (in Local Currency Unit) of Iraq in 2003?
Offer a very short reply. -2.22e+13. What is the difference between the Exports (in Local Currency Unit) in Germany in 2002 and the Exports (in Local Currency Unit) in Oman in 2003?
Your answer should be compact. 7.16e+11. What is the difference between the Exports (in Local Currency Unit) of Iraq in 2002 and the Exports (in Local Currency Unit) of Oman in 2003?
Make the answer very short. 2.89e+13. What is the average Exports (in Local Currency Unit) in Chile per year?
Your response must be concise. 1.24e+13. What is the average Exports (in Local Currency Unit) of Germany per year?
Your answer should be compact. 6.03e+11. What is the average Exports (in Local Currency Unit) in Iraq per year?
Make the answer very short. 2.08e+13. What is the average Exports (in Local Currency Unit) of Oman per year?
Ensure brevity in your answer.  3.38e+09. In the year 1996, what is the difference between the Exports (in Local Currency Unit) in Chile and Exports (in Local Currency Unit) in Germany?
Offer a terse response. 8.08e+12. In the year 1996, what is the difference between the Exports (in Local Currency Unit) in Chile and Exports (in Local Currency Unit) in Iraq?
Provide a short and direct response. 8.52e+12. In the year 1996, what is the difference between the Exports (in Local Currency Unit) of Chile and Exports (in Local Currency Unit) of Oman?
Provide a succinct answer. 8.52e+12. In the year 1996, what is the difference between the Exports (in Local Currency Unit) of Germany and Exports (in Local Currency Unit) of Iraq?
Offer a terse response. 4.41e+11. In the year 1996, what is the difference between the Exports (in Local Currency Unit) of Germany and Exports (in Local Currency Unit) of Oman?
Provide a succinct answer. 4.38e+11. In the year 1996, what is the difference between the Exports (in Local Currency Unit) in Iraq and Exports (in Local Currency Unit) in Oman?
Your answer should be very brief. -2.33e+09. In the year 1997, what is the difference between the Exports (in Local Currency Unit) of Chile and Exports (in Local Currency Unit) of Germany?
Your answer should be very brief. 8.90e+12. In the year 1997, what is the difference between the Exports (in Local Currency Unit) in Chile and Exports (in Local Currency Unit) in Iraq?
Offer a terse response. -2.32e+11. In the year 1997, what is the difference between the Exports (in Local Currency Unit) in Chile and Exports (in Local Currency Unit) in Oman?
Provide a succinct answer. 9.40e+12. In the year 1997, what is the difference between the Exports (in Local Currency Unit) in Germany and Exports (in Local Currency Unit) in Iraq?
Ensure brevity in your answer.  -9.14e+12. In the year 1997, what is the difference between the Exports (in Local Currency Unit) in Germany and Exports (in Local Currency Unit) in Oman?
Make the answer very short. 4.96e+11. In the year 1997, what is the difference between the Exports (in Local Currency Unit) of Iraq and Exports (in Local Currency Unit) of Oman?
Your answer should be compact. 9.63e+12. In the year 1998, what is the difference between the Exports (in Local Currency Unit) of Chile and Exports (in Local Currency Unit) of Germany?
Provide a succinct answer. 9.07e+12. In the year 1998, what is the difference between the Exports (in Local Currency Unit) in Chile and Exports (in Local Currency Unit) in Iraq?
Make the answer very short. -3.73e+12. In the year 1998, what is the difference between the Exports (in Local Currency Unit) of Chile and Exports (in Local Currency Unit) of Oman?
Give a very brief answer. 9.61e+12. In the year 1998, what is the difference between the Exports (in Local Currency Unit) in Germany and Exports (in Local Currency Unit) in Iraq?
Your response must be concise. -1.28e+13. In the year 1998, what is the difference between the Exports (in Local Currency Unit) of Germany and Exports (in Local Currency Unit) of Oman?
Ensure brevity in your answer.  5.32e+11. In the year 1998, what is the difference between the Exports (in Local Currency Unit) of Iraq and Exports (in Local Currency Unit) of Oman?
Keep it short and to the point. 1.33e+13. In the year 1999, what is the difference between the Exports (in Local Currency Unit) in Chile and Exports (in Local Currency Unit) in Germany?
Provide a short and direct response. 1.04e+13. In the year 1999, what is the difference between the Exports (in Local Currency Unit) in Chile and Exports (in Local Currency Unit) in Iraq?
Make the answer very short. -1.58e+13. In the year 1999, what is the difference between the Exports (in Local Currency Unit) in Chile and Exports (in Local Currency Unit) in Oman?
Provide a succinct answer. 1.10e+13. In the year 1999, what is the difference between the Exports (in Local Currency Unit) in Germany and Exports (in Local Currency Unit) in Iraq?
Make the answer very short. -2.62e+13. In the year 1999, what is the difference between the Exports (in Local Currency Unit) of Germany and Exports (in Local Currency Unit) of Oman?
Offer a very short reply. 5.55e+11. In the year 1999, what is the difference between the Exports (in Local Currency Unit) of Iraq and Exports (in Local Currency Unit) of Oman?
Make the answer very short. 2.68e+13. In the year 2000, what is the difference between the Exports (in Local Currency Unit) of Chile and Exports (in Local Currency Unit) of Germany?
Offer a very short reply. 1.19e+13. In the year 2000, what is the difference between the Exports (in Local Currency Unit) in Chile and Exports (in Local Currency Unit) in Iraq?
Give a very brief answer. -2.55e+13. In the year 2000, what is the difference between the Exports (in Local Currency Unit) in Chile and Exports (in Local Currency Unit) in Oman?
Offer a terse response. 1.25e+13. In the year 2000, what is the difference between the Exports (in Local Currency Unit) of Germany and Exports (in Local Currency Unit) of Iraq?
Ensure brevity in your answer.  -3.74e+13. In the year 2000, what is the difference between the Exports (in Local Currency Unit) of Germany and Exports (in Local Currency Unit) of Oman?
Your response must be concise. 6.48e+11. In the year 2000, what is the difference between the Exports (in Local Currency Unit) of Iraq and Exports (in Local Currency Unit) of Oman?
Provide a succinct answer. 3.80e+13. In the year 2001, what is the difference between the Exports (in Local Currency Unit) of Chile and Exports (in Local Currency Unit) of Germany?
Provide a succinct answer. 1.35e+13. In the year 2001, what is the difference between the Exports (in Local Currency Unit) in Chile and Exports (in Local Currency Unit) in Iraq?
Provide a short and direct response. -1.28e+13. In the year 2001, what is the difference between the Exports (in Local Currency Unit) of Chile and Exports (in Local Currency Unit) of Oman?
Your answer should be very brief. 1.42e+13. In the year 2001, what is the difference between the Exports (in Local Currency Unit) of Germany and Exports (in Local Currency Unit) of Iraq?
Your answer should be very brief. -2.63e+13. In the year 2001, what is the difference between the Exports (in Local Currency Unit) in Germany and Exports (in Local Currency Unit) in Oman?
Make the answer very short. 6.91e+11. In the year 2001, what is the difference between the Exports (in Local Currency Unit) in Iraq and Exports (in Local Currency Unit) in Oman?
Ensure brevity in your answer.  2.70e+13. In the year 2002, what is the difference between the Exports (in Local Currency Unit) in Chile and Exports (in Local Currency Unit) in Germany?
Your response must be concise. 1.47e+13. In the year 2002, what is the difference between the Exports (in Local Currency Unit) in Chile and Exports (in Local Currency Unit) in Iraq?
Offer a terse response. -1.35e+13. In the year 2002, what is the difference between the Exports (in Local Currency Unit) in Chile and Exports (in Local Currency Unit) in Oman?
Ensure brevity in your answer.  1.54e+13. In the year 2002, what is the difference between the Exports (in Local Currency Unit) of Germany and Exports (in Local Currency Unit) of Iraq?
Give a very brief answer. -2.82e+13. In the year 2002, what is the difference between the Exports (in Local Currency Unit) in Germany and Exports (in Local Currency Unit) in Oman?
Your answer should be very brief. 7.16e+11. In the year 2002, what is the difference between the Exports (in Local Currency Unit) in Iraq and Exports (in Local Currency Unit) in Oman?
Your response must be concise. 2.89e+13. In the year 2003, what is the difference between the Exports (in Local Currency Unit) of Chile and Exports (in Local Currency Unit) of Germany?
Your answer should be compact. 1.75e+13. In the year 2003, what is the difference between the Exports (in Local Currency Unit) in Chile and Exports (in Local Currency Unit) in Iraq?
Offer a terse response. -4.64e+12. In the year 2003, what is the difference between the Exports (in Local Currency Unit) of Chile and Exports (in Local Currency Unit) of Oman?
Your answer should be compact. 1.83e+13. In the year 2003, what is the difference between the Exports (in Local Currency Unit) of Germany and Exports (in Local Currency Unit) of Iraq?
Offer a terse response. -2.22e+13. In the year 2003, what is the difference between the Exports (in Local Currency Unit) in Germany and Exports (in Local Currency Unit) in Oman?
Provide a short and direct response. 7.19e+11. In the year 2003, what is the difference between the Exports (in Local Currency Unit) in Iraq and Exports (in Local Currency Unit) in Oman?
Keep it short and to the point. 2.29e+13. What is the ratio of the Exports (in Local Currency Unit) in Chile in 1996 to that in 1997?
Your response must be concise. 0.91. What is the ratio of the Exports (in Local Currency Unit) in Germany in 1996 to that in 1997?
Offer a terse response. 0.88. What is the ratio of the Exports (in Local Currency Unit) in Iraq in 1996 to that in 1997?
Give a very brief answer. 0. What is the ratio of the Exports (in Local Currency Unit) of Oman in 1996 to that in 1997?
Provide a short and direct response. 0.96. What is the ratio of the Exports (in Local Currency Unit) of Chile in 1996 to that in 1998?
Your answer should be compact. 0.89. What is the ratio of the Exports (in Local Currency Unit) in Germany in 1996 to that in 1998?
Keep it short and to the point. 0.83. What is the ratio of the Exports (in Local Currency Unit) of Oman in 1996 to that in 1998?
Make the answer very short. 1.29. What is the ratio of the Exports (in Local Currency Unit) in Chile in 1996 to that in 1999?
Provide a short and direct response. 0.78. What is the ratio of the Exports (in Local Currency Unit) of Germany in 1996 to that in 1999?
Give a very brief answer. 0.79. What is the ratio of the Exports (in Local Currency Unit) in Iraq in 1996 to that in 1999?
Offer a terse response. 0. What is the ratio of the Exports (in Local Currency Unit) in Chile in 1996 to that in 2000?
Provide a short and direct response. 0.68. What is the ratio of the Exports (in Local Currency Unit) in Germany in 1996 to that in 2000?
Ensure brevity in your answer.  0.68. What is the ratio of the Exports (in Local Currency Unit) of Iraq in 1996 to that in 2000?
Provide a succinct answer. 0. What is the ratio of the Exports (in Local Currency Unit) of Oman in 1996 to that in 2000?
Keep it short and to the point. 0.73. What is the ratio of the Exports (in Local Currency Unit) in Chile in 1996 to that in 2001?
Offer a terse response. 0.6. What is the ratio of the Exports (in Local Currency Unit) of Germany in 1996 to that in 2001?
Your answer should be very brief. 0.64. What is the ratio of the Exports (in Local Currency Unit) of Iraq in 1996 to that in 2001?
Offer a very short reply. 0. What is the ratio of the Exports (in Local Currency Unit) of Oman in 1996 to that in 2001?
Give a very brief answer. 0.76. What is the ratio of the Exports (in Local Currency Unit) of Chile in 1996 to that in 2002?
Keep it short and to the point. 0.55. What is the ratio of the Exports (in Local Currency Unit) in Germany in 1996 to that in 2002?
Offer a very short reply. 0.61. What is the ratio of the Exports (in Local Currency Unit) of Iraq in 1996 to that in 2002?
Your response must be concise. 0. What is the ratio of the Exports (in Local Currency Unit) in Oman in 1996 to that in 2002?
Give a very brief answer. 0.77. What is the ratio of the Exports (in Local Currency Unit) in Chile in 1996 to that in 2003?
Offer a terse response. 0.47. What is the ratio of the Exports (in Local Currency Unit) of Germany in 1996 to that in 2003?
Give a very brief answer. 0.61. What is the ratio of the Exports (in Local Currency Unit) in Iraq in 1996 to that in 2003?
Offer a very short reply. 0. What is the ratio of the Exports (in Local Currency Unit) of Oman in 1996 to that in 2003?
Your response must be concise. 0.71. What is the ratio of the Exports (in Local Currency Unit) in Chile in 1997 to that in 1998?
Ensure brevity in your answer.  0.98. What is the ratio of the Exports (in Local Currency Unit) of Germany in 1997 to that in 1998?
Keep it short and to the point. 0.94. What is the ratio of the Exports (in Local Currency Unit) in Iraq in 1997 to that in 1998?
Keep it short and to the point. 0.72. What is the ratio of the Exports (in Local Currency Unit) of Oman in 1997 to that in 1998?
Offer a very short reply. 1.34. What is the ratio of the Exports (in Local Currency Unit) of Chile in 1997 to that in 1999?
Keep it short and to the point. 0.86. What is the ratio of the Exports (in Local Currency Unit) in Germany in 1997 to that in 1999?
Your answer should be very brief. 0.89. What is the ratio of the Exports (in Local Currency Unit) in Iraq in 1997 to that in 1999?
Ensure brevity in your answer.  0.36. What is the ratio of the Exports (in Local Currency Unit) in Oman in 1997 to that in 1999?
Make the answer very short. 1.04. What is the ratio of the Exports (in Local Currency Unit) of Chile in 1997 to that in 2000?
Offer a very short reply. 0.75. What is the ratio of the Exports (in Local Currency Unit) of Germany in 1997 to that in 2000?
Keep it short and to the point. 0.77. What is the ratio of the Exports (in Local Currency Unit) of Iraq in 1997 to that in 2000?
Make the answer very short. 0.25. What is the ratio of the Exports (in Local Currency Unit) in Oman in 1997 to that in 2000?
Offer a terse response. 0.76. What is the ratio of the Exports (in Local Currency Unit) in Chile in 1997 to that in 2001?
Keep it short and to the point. 0.66. What is the ratio of the Exports (in Local Currency Unit) in Germany in 1997 to that in 2001?
Offer a very short reply. 0.72. What is the ratio of the Exports (in Local Currency Unit) of Iraq in 1997 to that in 2001?
Give a very brief answer. 0.36. What is the ratio of the Exports (in Local Currency Unit) in Oman in 1997 to that in 2001?
Your answer should be very brief. 0.79. What is the ratio of the Exports (in Local Currency Unit) in Chile in 1997 to that in 2002?
Ensure brevity in your answer.  0.61. What is the ratio of the Exports (in Local Currency Unit) of Germany in 1997 to that in 2002?
Your answer should be very brief. 0.69. What is the ratio of the Exports (in Local Currency Unit) in Iraq in 1997 to that in 2002?
Give a very brief answer. 0.33. What is the ratio of the Exports (in Local Currency Unit) of Oman in 1997 to that in 2002?
Make the answer very short. 0.8. What is the ratio of the Exports (in Local Currency Unit) of Chile in 1997 to that in 2003?
Provide a succinct answer. 0.52. What is the ratio of the Exports (in Local Currency Unit) of Germany in 1997 to that in 2003?
Keep it short and to the point. 0.69. What is the ratio of the Exports (in Local Currency Unit) of Iraq in 1997 to that in 2003?
Make the answer very short. 0.42. What is the ratio of the Exports (in Local Currency Unit) of Oman in 1997 to that in 2003?
Your answer should be compact. 0.74. What is the ratio of the Exports (in Local Currency Unit) of Chile in 1998 to that in 1999?
Make the answer very short. 0.87. What is the ratio of the Exports (in Local Currency Unit) of Germany in 1998 to that in 1999?
Your response must be concise. 0.96. What is the ratio of the Exports (in Local Currency Unit) in Iraq in 1998 to that in 1999?
Provide a succinct answer. 0.5. What is the ratio of the Exports (in Local Currency Unit) in Oman in 1998 to that in 1999?
Ensure brevity in your answer.  0.77. What is the ratio of the Exports (in Local Currency Unit) in Chile in 1998 to that in 2000?
Offer a very short reply. 0.77. What is the ratio of the Exports (in Local Currency Unit) of Germany in 1998 to that in 2000?
Offer a terse response. 0.82. What is the ratio of the Exports (in Local Currency Unit) in Iraq in 1998 to that in 2000?
Make the answer very short. 0.35. What is the ratio of the Exports (in Local Currency Unit) of Oman in 1998 to that in 2000?
Make the answer very short. 0.56. What is the ratio of the Exports (in Local Currency Unit) in Chile in 1998 to that in 2001?
Offer a terse response. 0.68. What is the ratio of the Exports (in Local Currency Unit) of Germany in 1998 to that in 2001?
Provide a short and direct response. 0.77. What is the ratio of the Exports (in Local Currency Unit) in Iraq in 1998 to that in 2001?
Your answer should be compact. 0.49. What is the ratio of the Exports (in Local Currency Unit) in Oman in 1998 to that in 2001?
Ensure brevity in your answer.  0.59. What is the ratio of the Exports (in Local Currency Unit) of Chile in 1998 to that in 2002?
Give a very brief answer. 0.62. What is the ratio of the Exports (in Local Currency Unit) of Germany in 1998 to that in 2002?
Offer a terse response. 0.74. What is the ratio of the Exports (in Local Currency Unit) of Iraq in 1998 to that in 2002?
Provide a succinct answer. 0.46. What is the ratio of the Exports (in Local Currency Unit) of Oman in 1998 to that in 2002?
Offer a terse response. 0.6. What is the ratio of the Exports (in Local Currency Unit) in Chile in 1998 to that in 2003?
Offer a terse response. 0.53. What is the ratio of the Exports (in Local Currency Unit) in Germany in 1998 to that in 2003?
Your response must be concise. 0.74. What is the ratio of the Exports (in Local Currency Unit) of Iraq in 1998 to that in 2003?
Your response must be concise. 0.58. What is the ratio of the Exports (in Local Currency Unit) of Oman in 1998 to that in 2003?
Offer a very short reply. 0.55. What is the ratio of the Exports (in Local Currency Unit) of Chile in 1999 to that in 2000?
Your answer should be compact. 0.88. What is the ratio of the Exports (in Local Currency Unit) of Germany in 1999 to that in 2000?
Offer a very short reply. 0.86. What is the ratio of the Exports (in Local Currency Unit) of Iraq in 1999 to that in 2000?
Your answer should be very brief. 0.7. What is the ratio of the Exports (in Local Currency Unit) of Oman in 1999 to that in 2000?
Offer a very short reply. 0.73. What is the ratio of the Exports (in Local Currency Unit) in Chile in 1999 to that in 2001?
Keep it short and to the point. 0.78. What is the ratio of the Exports (in Local Currency Unit) in Germany in 1999 to that in 2001?
Give a very brief answer. 0.8. What is the ratio of the Exports (in Local Currency Unit) of Iraq in 1999 to that in 2001?
Offer a terse response. 0.99. What is the ratio of the Exports (in Local Currency Unit) of Oman in 1999 to that in 2001?
Offer a very short reply. 0.76. What is the ratio of the Exports (in Local Currency Unit) in Chile in 1999 to that in 2002?
Your answer should be very brief. 0.71. What is the ratio of the Exports (in Local Currency Unit) in Germany in 1999 to that in 2002?
Offer a very short reply. 0.78. What is the ratio of the Exports (in Local Currency Unit) of Iraq in 1999 to that in 2002?
Offer a very short reply. 0.92. What is the ratio of the Exports (in Local Currency Unit) of Oman in 1999 to that in 2002?
Offer a terse response. 0.77. What is the ratio of the Exports (in Local Currency Unit) in Chile in 1999 to that in 2003?
Ensure brevity in your answer.  0.6. What is the ratio of the Exports (in Local Currency Unit) in Germany in 1999 to that in 2003?
Provide a short and direct response. 0.77. What is the ratio of the Exports (in Local Currency Unit) of Iraq in 1999 to that in 2003?
Offer a very short reply. 1.17. What is the ratio of the Exports (in Local Currency Unit) in Oman in 1999 to that in 2003?
Make the answer very short. 0.71. What is the ratio of the Exports (in Local Currency Unit) of Chile in 2000 to that in 2001?
Give a very brief answer. 0.88. What is the ratio of the Exports (in Local Currency Unit) in Germany in 2000 to that in 2001?
Your response must be concise. 0.94. What is the ratio of the Exports (in Local Currency Unit) in Iraq in 2000 to that in 2001?
Give a very brief answer. 1.41. What is the ratio of the Exports (in Local Currency Unit) in Oman in 2000 to that in 2001?
Offer a terse response. 1.04. What is the ratio of the Exports (in Local Currency Unit) of Chile in 2000 to that in 2002?
Provide a succinct answer. 0.81. What is the ratio of the Exports (in Local Currency Unit) of Germany in 2000 to that in 2002?
Your response must be concise. 0.91. What is the ratio of the Exports (in Local Currency Unit) in Iraq in 2000 to that in 2002?
Ensure brevity in your answer.  1.31. What is the ratio of the Exports (in Local Currency Unit) in Oman in 2000 to that in 2002?
Provide a short and direct response. 1.06. What is the ratio of the Exports (in Local Currency Unit) of Chile in 2000 to that in 2003?
Make the answer very short. 0.69. What is the ratio of the Exports (in Local Currency Unit) in Germany in 2000 to that in 2003?
Offer a very short reply. 0.9. What is the ratio of the Exports (in Local Currency Unit) of Iraq in 2000 to that in 2003?
Your answer should be compact. 1.66. What is the ratio of the Exports (in Local Currency Unit) of Oman in 2000 to that in 2003?
Give a very brief answer. 0.97. What is the ratio of the Exports (in Local Currency Unit) of Chile in 2001 to that in 2002?
Keep it short and to the point. 0.92. What is the ratio of the Exports (in Local Currency Unit) in Germany in 2001 to that in 2002?
Your answer should be compact. 0.97. What is the ratio of the Exports (in Local Currency Unit) in Iraq in 2001 to that in 2002?
Give a very brief answer. 0.93. What is the ratio of the Exports (in Local Currency Unit) in Oman in 2001 to that in 2002?
Ensure brevity in your answer.  1.02. What is the ratio of the Exports (in Local Currency Unit) of Chile in 2001 to that in 2003?
Give a very brief answer. 0.78. What is the ratio of the Exports (in Local Currency Unit) in Germany in 2001 to that in 2003?
Provide a succinct answer. 0.96. What is the ratio of the Exports (in Local Currency Unit) in Iraq in 2001 to that in 2003?
Offer a terse response. 1.18. What is the ratio of the Exports (in Local Currency Unit) of Oman in 2001 to that in 2003?
Make the answer very short. 0.93. What is the ratio of the Exports (in Local Currency Unit) of Chile in 2002 to that in 2003?
Your answer should be very brief. 0.84. What is the ratio of the Exports (in Local Currency Unit) of Iraq in 2002 to that in 2003?
Provide a short and direct response. 1.26. What is the ratio of the Exports (in Local Currency Unit) of Oman in 2002 to that in 2003?
Your response must be concise. 0.92. What is the difference between the highest and the second highest Exports (in Local Currency Unit) in Chile?
Keep it short and to the point. 2.83e+12. What is the difference between the highest and the second highest Exports (in Local Currency Unit) of Germany?
Ensure brevity in your answer.  3.90e+09. What is the difference between the highest and the second highest Exports (in Local Currency Unit) of Iraq?
Keep it short and to the point. 9.06e+12. What is the difference between the highest and the second highest Exports (in Local Currency Unit) in Oman?
Give a very brief answer. 1.12e+08. What is the difference between the highest and the lowest Exports (in Local Currency Unit) in Chile?
Your response must be concise. 9.74e+12. What is the difference between the highest and the lowest Exports (in Local Currency Unit) in Germany?
Your response must be concise. 2.82e+11. What is the difference between the highest and the lowest Exports (in Local Currency Unit) in Iraq?
Provide a succinct answer. 3.80e+13. What is the difference between the highest and the lowest Exports (in Local Currency Unit) of Oman?
Your answer should be very brief. 1.87e+09. 